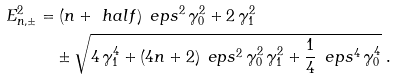Convert formula to latex. <formula><loc_0><loc_0><loc_500><loc_500>E _ { n , \pm } ^ { 2 } & = ( n + \ h a l f ) \, \ e p s ^ { 2 } \, \gamma _ { 0 } ^ { 2 } + 2 \, \gamma _ { 1 } ^ { 2 } \\ & \quad \pm \sqrt { 4 \, \gamma _ { 1 } ^ { 4 } + ( 4 n + 2 ) \, \ e p s ^ { 2 } \, \gamma _ { 0 } ^ { 2 } \, \gamma _ { 1 } ^ { 2 } + \frac { 1 } { 4 } \, \ e p s ^ { 4 } \, \gamma _ { 0 } ^ { 4 } } \ .</formula> 